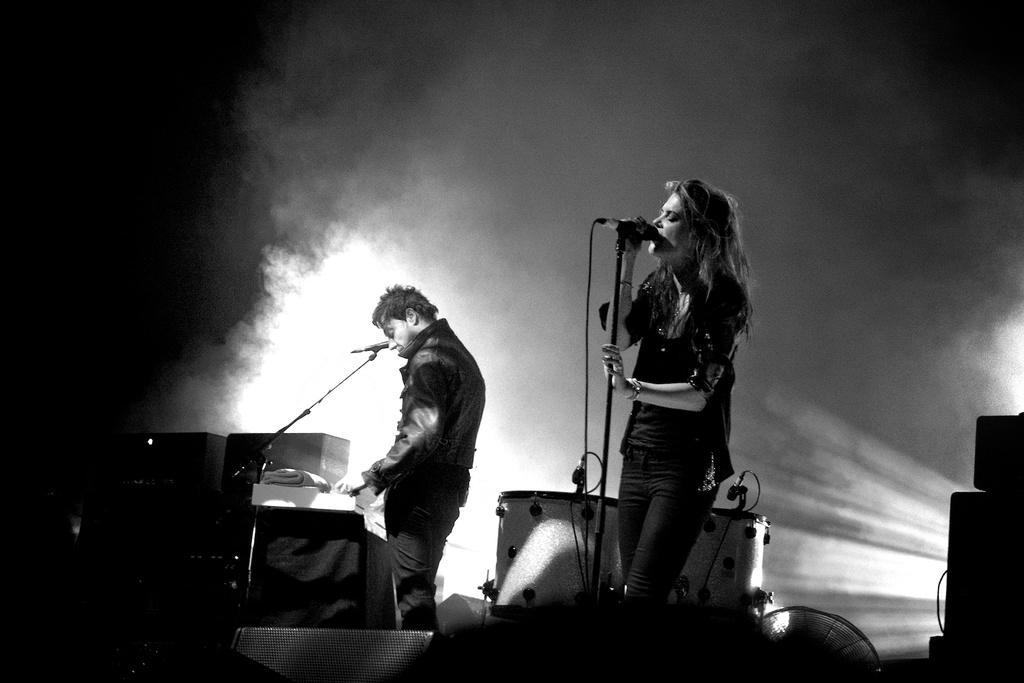Describe this image in one or two sentences. In this image I can see the black and white picture in which I can see the stage and on the stage I can see two persons standing and microphones in front of them. I can see few musical instruments, some smoke and the dark background. 